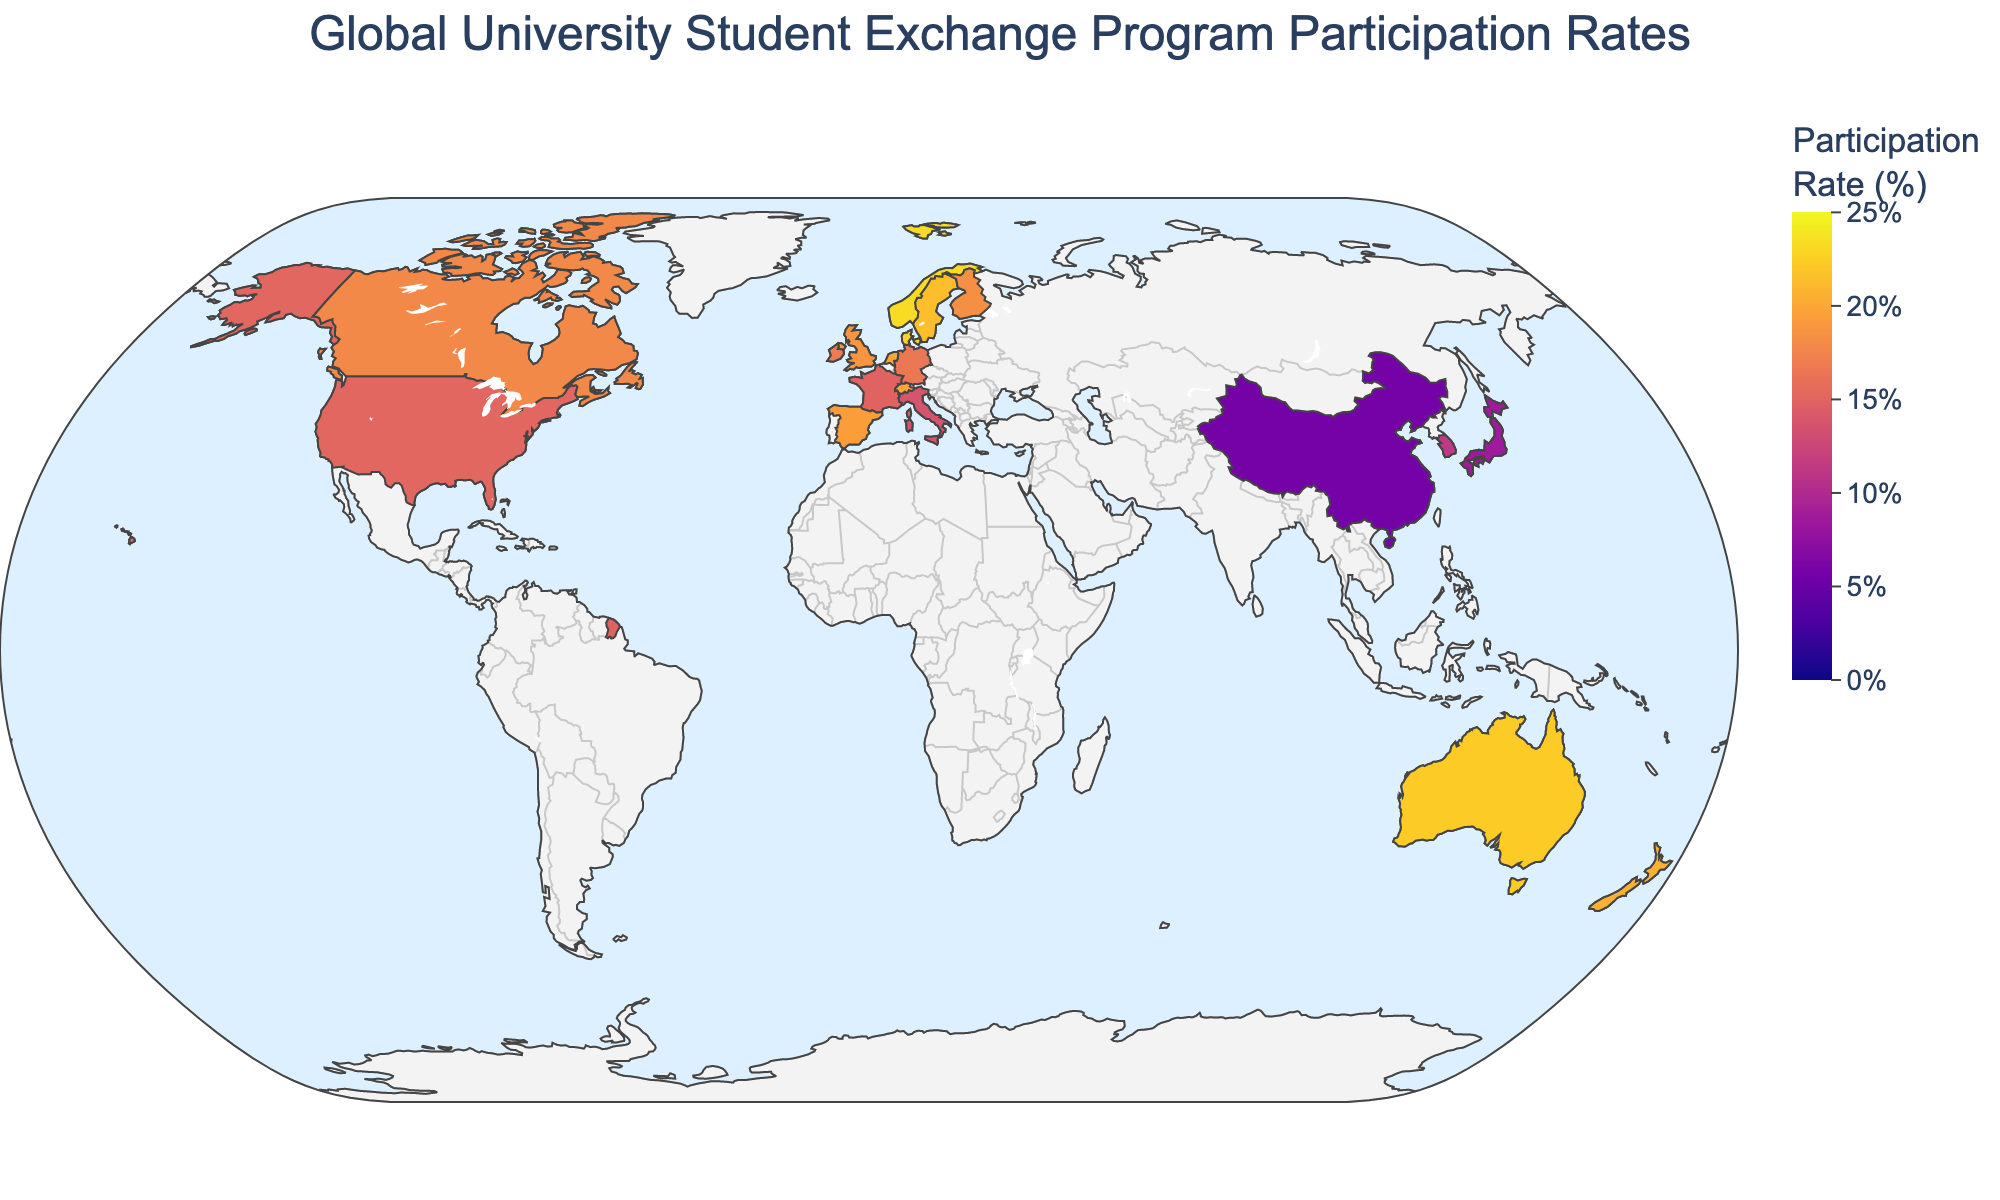What is the title of the figure? The title is located at the top center of the figure and reads "Global University Student Exchange Program Participation Rates".
Answer: Global University Student Exchange Program Participation Rates Which country has the highest student exchange participation rate? By examining the choropleth map, the country with the highest participation rate is colored in the deepest shade. Norway has the highest rate.
Answer: Norway What is the range of participation rates displayed in the color bar? The color bar legend on the right indicates that the participation rates range from 0% to 25%.
Answer: 0% to 25% What are the participation rates for Sweden and Denmark? By referring to the choropleth map, Sweden is shown with a participation rate of 21.5%, and Denmark with a participation rate of 22.8%.
Answer: Sweden: 21.5%, Denmark: 22.8% How does the participation rate of Japan compare to that of China? Japan has a participation rate of 8.6% while China has a participation rate of 5.7%, as indicated by their respective shades on the map. Therefore, Japan's rate is higher than China's.
Answer: Japan's rate is higher than China's Which country has a higher participation rate, Australia or the United States? By checking the map, Australia has a participation rate of 22.3%, which is higher than the United States' rate of 15.2%.
Answer: Australia What is the average participation rate among the Nordic countries (Denmark, Finland, Norway, Sweden)? The participation rates for the Nordic countries are: Denmark (22.8%), Finland (18.3%), Norway (23.2%), Sweden (21.5%). The average is calculated as (22.8 + 18.3 + 23.2 + 21.5) / 4 = 21.45%.
Answer: 21.45% What is the difference in participation rates between Spain and Germany? Spain has a participation rate of 19.4% and Germany has 16.5%, so the difference is 19.4% - 16.5% = 2.9%.
Answer: 2.9% Which countries have participation rates higher than 20%? By inspecting the shades on the map, the countries with participation rates higher than 20% are Australia, Denmark, Netherlands, New Zealand, Norway, and Sweden.
Answer: Australia, Denmark, Netherlands, New Zealand, Norway, Sweden What is the pattern of participation rates across continents? By observing the choropleth map, European countries generally have higher participation rates, with many above 15%. Oceania countries also have high rates, while Asian countries like China and Japan have lower rates.
Answer: Europe and Oceania generally higher, Asia lower 